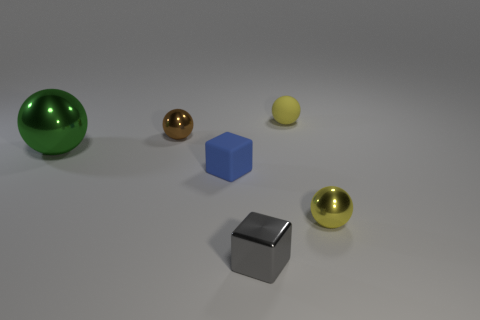How many blocks are either small blue objects or gray shiny objects?
Provide a succinct answer. 2. Are there any other things of the same color as the big shiny thing?
Your answer should be very brief. No. What material is the tiny ball that is behind the tiny metallic sphere that is to the left of the yellow matte thing made of?
Give a very brief answer. Rubber. Is the gray thing made of the same material as the tiny yellow object that is behind the blue matte block?
Offer a very short reply. No. How many things are tiny spheres that are to the right of the tiny gray metallic object or metal things?
Provide a succinct answer. 5. Is there a large sphere that has the same color as the large shiny object?
Provide a short and direct response. No. There is a small gray object; is its shape the same as the yellow object that is in front of the brown metallic sphere?
Ensure brevity in your answer.  No. How many small things are both in front of the tiny brown ball and to the left of the gray thing?
Your answer should be compact. 1. There is a tiny brown thing that is the same shape as the big green metallic thing; what is its material?
Provide a short and direct response. Metal. What size is the sphere left of the small shiny object that is behind the blue matte block?
Keep it short and to the point. Large. 